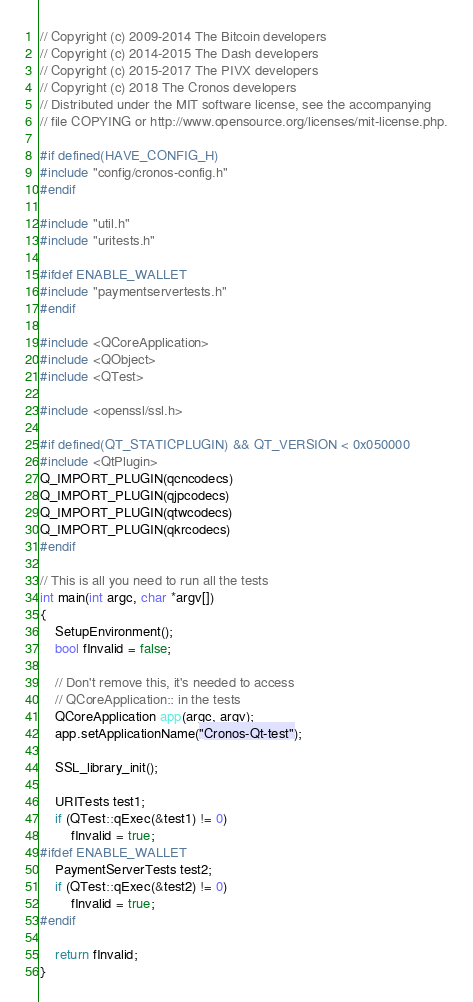<code> <loc_0><loc_0><loc_500><loc_500><_C++_>// Copyright (c) 2009-2014 The Bitcoin developers
// Copyright (c) 2014-2015 The Dash developers
// Copyright (c) 2015-2017 The PIVX developers
// Copyright (c) 2018 The Cronos developers
// Distributed under the MIT software license, see the accompanying
// file COPYING or http://www.opensource.org/licenses/mit-license.php.

#if defined(HAVE_CONFIG_H)
#include "config/cronos-config.h"
#endif

#include "util.h"
#include "uritests.h"

#ifdef ENABLE_WALLET
#include "paymentservertests.h"
#endif

#include <QCoreApplication>
#include <QObject>
#include <QTest>

#include <openssl/ssl.h>

#if defined(QT_STATICPLUGIN) && QT_VERSION < 0x050000
#include <QtPlugin>
Q_IMPORT_PLUGIN(qcncodecs)
Q_IMPORT_PLUGIN(qjpcodecs)
Q_IMPORT_PLUGIN(qtwcodecs)
Q_IMPORT_PLUGIN(qkrcodecs)
#endif

// This is all you need to run all the tests
int main(int argc, char *argv[])
{
    SetupEnvironment();
    bool fInvalid = false;

    // Don't remove this, it's needed to access
    // QCoreApplication:: in the tests
    QCoreApplication app(argc, argv);
    app.setApplicationName("Cronos-Qt-test");

    SSL_library_init();

    URITests test1;
    if (QTest::qExec(&test1) != 0)
        fInvalid = true;
#ifdef ENABLE_WALLET
    PaymentServerTests test2;
    if (QTest::qExec(&test2) != 0)
        fInvalid = true;
#endif

    return fInvalid;
}
</code> 